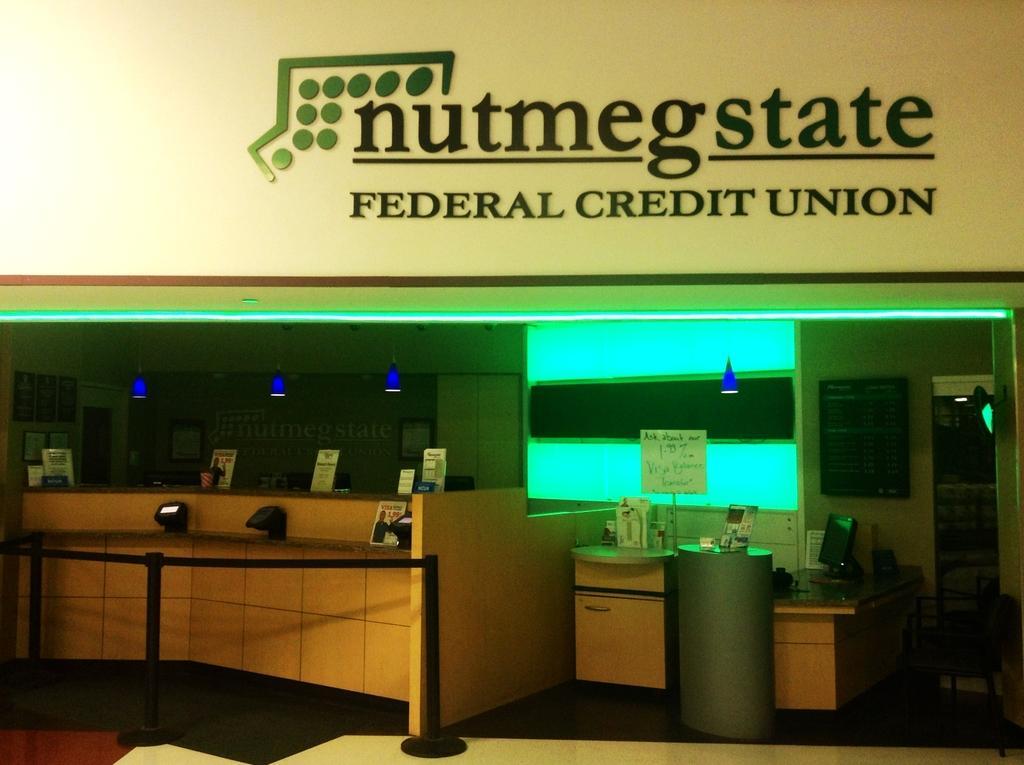Describe this image in one or two sentences. In this image there are boards , stanchions ,monitor and some objects on the tables, chair, lights, television and frames attached to the wall. 